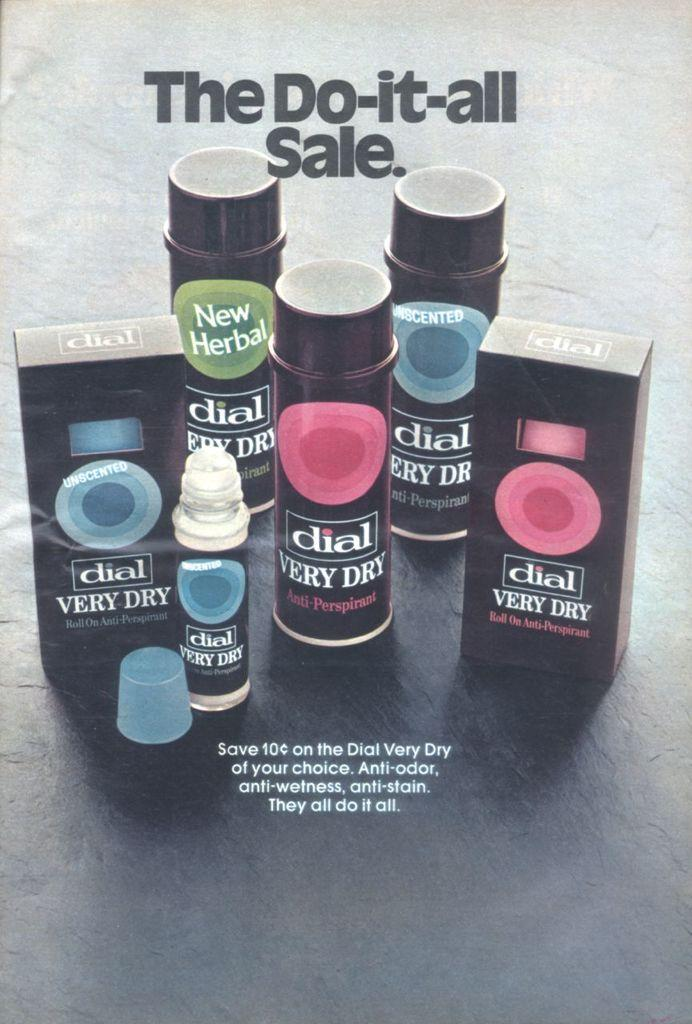<image>
Render a clear and concise summary of the photo. Very dry dial anti-perspirant is on sale and does it all. 